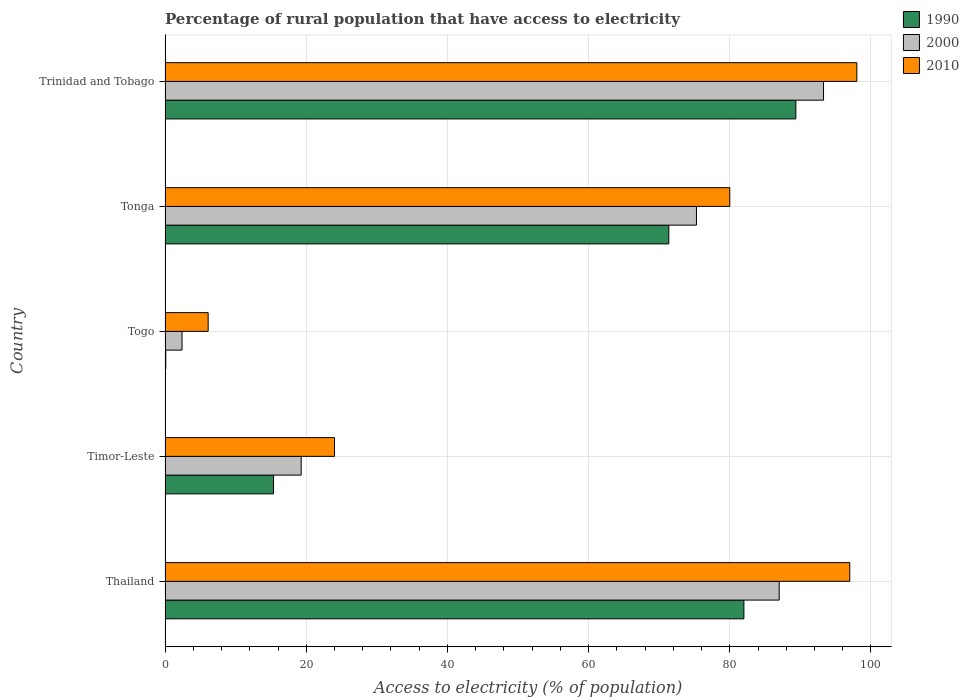How many groups of bars are there?
Make the answer very short. 5. Are the number of bars per tick equal to the number of legend labels?
Provide a succinct answer. Yes. Are the number of bars on each tick of the Y-axis equal?
Your answer should be very brief. Yes. What is the label of the 2nd group of bars from the top?
Your answer should be very brief. Tonga. In how many cases, is the number of bars for a given country not equal to the number of legend labels?
Your response must be concise. 0. Across all countries, what is the maximum percentage of rural population that have access to electricity in 2000?
Provide a short and direct response. 93.28. In which country was the percentage of rural population that have access to electricity in 1990 maximum?
Make the answer very short. Trinidad and Tobago. In which country was the percentage of rural population that have access to electricity in 2000 minimum?
Give a very brief answer. Togo. What is the total percentage of rural population that have access to electricity in 2000 in the graph?
Keep it short and to the point. 277.24. What is the difference between the percentage of rural population that have access to electricity in 2000 in Thailand and that in Timor-Leste?
Your response must be concise. 67.72. What is the difference between the percentage of rural population that have access to electricity in 2000 in Tonga and the percentage of rural population that have access to electricity in 1990 in Thailand?
Your answer should be very brief. -6.72. What is the average percentage of rural population that have access to electricity in 2010 per country?
Your answer should be very brief. 61.02. What is the difference between the percentage of rural population that have access to electricity in 1990 and percentage of rural population that have access to electricity in 2000 in Trinidad and Tobago?
Keep it short and to the point. -3.92. In how many countries, is the percentage of rural population that have access to electricity in 1990 greater than 56 %?
Your response must be concise. 3. What is the ratio of the percentage of rural population that have access to electricity in 2000 in Thailand to that in Tonga?
Your response must be concise. 1.16. What is the difference between the highest and the second highest percentage of rural population that have access to electricity in 2000?
Offer a very short reply. 6.28. What is the difference between the highest and the lowest percentage of rural population that have access to electricity in 2000?
Ensure brevity in your answer.  90.88. In how many countries, is the percentage of rural population that have access to electricity in 1990 greater than the average percentage of rural population that have access to electricity in 1990 taken over all countries?
Offer a very short reply. 3. What does the 2nd bar from the bottom in Thailand represents?
Your answer should be very brief. 2000. How many bars are there?
Offer a very short reply. 15. Are all the bars in the graph horizontal?
Your answer should be very brief. Yes. How many countries are there in the graph?
Make the answer very short. 5. What is the difference between two consecutive major ticks on the X-axis?
Provide a succinct answer. 20. Are the values on the major ticks of X-axis written in scientific E-notation?
Give a very brief answer. No. Does the graph contain grids?
Your response must be concise. Yes. Where does the legend appear in the graph?
Ensure brevity in your answer.  Top right. How many legend labels are there?
Make the answer very short. 3. What is the title of the graph?
Provide a succinct answer. Percentage of rural population that have access to electricity. Does "1971" appear as one of the legend labels in the graph?
Provide a short and direct response. No. What is the label or title of the X-axis?
Offer a very short reply. Access to electricity (% of population). What is the Access to electricity (% of population) of 2010 in Thailand?
Ensure brevity in your answer.  97. What is the Access to electricity (% of population) in 1990 in Timor-Leste?
Your answer should be compact. 15.36. What is the Access to electricity (% of population) in 2000 in Timor-Leste?
Your answer should be very brief. 19.28. What is the Access to electricity (% of population) of 2010 in Timor-Leste?
Keep it short and to the point. 24. What is the Access to electricity (% of population) of 2010 in Togo?
Give a very brief answer. 6.1. What is the Access to electricity (% of population) in 1990 in Tonga?
Keep it short and to the point. 71.36. What is the Access to electricity (% of population) in 2000 in Tonga?
Offer a terse response. 75.28. What is the Access to electricity (% of population) of 1990 in Trinidad and Tobago?
Offer a terse response. 89.36. What is the Access to electricity (% of population) of 2000 in Trinidad and Tobago?
Make the answer very short. 93.28. What is the Access to electricity (% of population) in 2010 in Trinidad and Tobago?
Provide a short and direct response. 98. Across all countries, what is the maximum Access to electricity (% of population) of 1990?
Your response must be concise. 89.36. Across all countries, what is the maximum Access to electricity (% of population) of 2000?
Provide a short and direct response. 93.28. Across all countries, what is the minimum Access to electricity (% of population) of 1990?
Your answer should be very brief. 0.1. Across all countries, what is the minimum Access to electricity (% of population) of 2000?
Your response must be concise. 2.4. Across all countries, what is the minimum Access to electricity (% of population) of 2010?
Provide a succinct answer. 6.1. What is the total Access to electricity (% of population) in 1990 in the graph?
Give a very brief answer. 258.18. What is the total Access to electricity (% of population) of 2000 in the graph?
Provide a succinct answer. 277.24. What is the total Access to electricity (% of population) of 2010 in the graph?
Provide a succinct answer. 305.1. What is the difference between the Access to electricity (% of population) of 1990 in Thailand and that in Timor-Leste?
Offer a very short reply. 66.64. What is the difference between the Access to electricity (% of population) in 2000 in Thailand and that in Timor-Leste?
Make the answer very short. 67.72. What is the difference between the Access to electricity (% of population) in 1990 in Thailand and that in Togo?
Keep it short and to the point. 81.9. What is the difference between the Access to electricity (% of population) in 2000 in Thailand and that in Togo?
Ensure brevity in your answer.  84.6. What is the difference between the Access to electricity (% of population) in 2010 in Thailand and that in Togo?
Make the answer very short. 90.9. What is the difference between the Access to electricity (% of population) in 1990 in Thailand and that in Tonga?
Give a very brief answer. 10.64. What is the difference between the Access to electricity (% of population) in 2000 in Thailand and that in Tonga?
Your answer should be very brief. 11.72. What is the difference between the Access to electricity (% of population) of 2010 in Thailand and that in Tonga?
Make the answer very short. 17. What is the difference between the Access to electricity (% of population) in 1990 in Thailand and that in Trinidad and Tobago?
Make the answer very short. -7.36. What is the difference between the Access to electricity (% of population) of 2000 in Thailand and that in Trinidad and Tobago?
Offer a terse response. -6.28. What is the difference between the Access to electricity (% of population) in 1990 in Timor-Leste and that in Togo?
Your answer should be very brief. 15.26. What is the difference between the Access to electricity (% of population) in 2000 in Timor-Leste and that in Togo?
Provide a short and direct response. 16.88. What is the difference between the Access to electricity (% of population) in 1990 in Timor-Leste and that in Tonga?
Ensure brevity in your answer.  -56. What is the difference between the Access to electricity (% of population) in 2000 in Timor-Leste and that in Tonga?
Keep it short and to the point. -56. What is the difference between the Access to electricity (% of population) of 2010 in Timor-Leste and that in Tonga?
Your answer should be very brief. -56. What is the difference between the Access to electricity (% of population) of 1990 in Timor-Leste and that in Trinidad and Tobago?
Offer a terse response. -74. What is the difference between the Access to electricity (% of population) of 2000 in Timor-Leste and that in Trinidad and Tobago?
Offer a very short reply. -74. What is the difference between the Access to electricity (% of population) in 2010 in Timor-Leste and that in Trinidad and Tobago?
Offer a very short reply. -74. What is the difference between the Access to electricity (% of population) in 1990 in Togo and that in Tonga?
Ensure brevity in your answer.  -71.26. What is the difference between the Access to electricity (% of population) in 2000 in Togo and that in Tonga?
Offer a very short reply. -72.88. What is the difference between the Access to electricity (% of population) in 2010 in Togo and that in Tonga?
Your answer should be compact. -73.9. What is the difference between the Access to electricity (% of population) in 1990 in Togo and that in Trinidad and Tobago?
Your answer should be very brief. -89.26. What is the difference between the Access to electricity (% of population) of 2000 in Togo and that in Trinidad and Tobago?
Make the answer very short. -90.88. What is the difference between the Access to electricity (% of population) in 2010 in Togo and that in Trinidad and Tobago?
Provide a succinct answer. -91.9. What is the difference between the Access to electricity (% of population) in 1990 in Tonga and that in Trinidad and Tobago?
Provide a short and direct response. -18. What is the difference between the Access to electricity (% of population) in 2010 in Tonga and that in Trinidad and Tobago?
Make the answer very short. -18. What is the difference between the Access to electricity (% of population) in 1990 in Thailand and the Access to electricity (% of population) in 2000 in Timor-Leste?
Your answer should be compact. 62.72. What is the difference between the Access to electricity (% of population) in 1990 in Thailand and the Access to electricity (% of population) in 2000 in Togo?
Give a very brief answer. 79.6. What is the difference between the Access to electricity (% of population) of 1990 in Thailand and the Access to electricity (% of population) of 2010 in Togo?
Your response must be concise. 75.9. What is the difference between the Access to electricity (% of population) in 2000 in Thailand and the Access to electricity (% of population) in 2010 in Togo?
Your response must be concise. 80.9. What is the difference between the Access to electricity (% of population) of 1990 in Thailand and the Access to electricity (% of population) of 2000 in Tonga?
Give a very brief answer. 6.72. What is the difference between the Access to electricity (% of population) of 1990 in Thailand and the Access to electricity (% of population) of 2000 in Trinidad and Tobago?
Give a very brief answer. -11.28. What is the difference between the Access to electricity (% of population) of 1990 in Thailand and the Access to electricity (% of population) of 2010 in Trinidad and Tobago?
Your response must be concise. -16. What is the difference between the Access to electricity (% of population) in 2000 in Thailand and the Access to electricity (% of population) in 2010 in Trinidad and Tobago?
Your response must be concise. -11. What is the difference between the Access to electricity (% of population) of 1990 in Timor-Leste and the Access to electricity (% of population) of 2000 in Togo?
Make the answer very short. 12.96. What is the difference between the Access to electricity (% of population) of 1990 in Timor-Leste and the Access to electricity (% of population) of 2010 in Togo?
Your answer should be compact. 9.26. What is the difference between the Access to electricity (% of population) of 2000 in Timor-Leste and the Access to electricity (% of population) of 2010 in Togo?
Give a very brief answer. 13.18. What is the difference between the Access to electricity (% of population) of 1990 in Timor-Leste and the Access to electricity (% of population) of 2000 in Tonga?
Your response must be concise. -59.92. What is the difference between the Access to electricity (% of population) in 1990 in Timor-Leste and the Access to electricity (% of population) in 2010 in Tonga?
Make the answer very short. -64.64. What is the difference between the Access to electricity (% of population) in 2000 in Timor-Leste and the Access to electricity (% of population) in 2010 in Tonga?
Provide a succinct answer. -60.72. What is the difference between the Access to electricity (% of population) in 1990 in Timor-Leste and the Access to electricity (% of population) in 2000 in Trinidad and Tobago?
Ensure brevity in your answer.  -77.92. What is the difference between the Access to electricity (% of population) of 1990 in Timor-Leste and the Access to electricity (% of population) of 2010 in Trinidad and Tobago?
Provide a short and direct response. -82.64. What is the difference between the Access to electricity (% of population) in 2000 in Timor-Leste and the Access to electricity (% of population) in 2010 in Trinidad and Tobago?
Your answer should be very brief. -78.72. What is the difference between the Access to electricity (% of population) in 1990 in Togo and the Access to electricity (% of population) in 2000 in Tonga?
Give a very brief answer. -75.18. What is the difference between the Access to electricity (% of population) of 1990 in Togo and the Access to electricity (% of population) of 2010 in Tonga?
Offer a very short reply. -79.9. What is the difference between the Access to electricity (% of population) of 2000 in Togo and the Access to electricity (% of population) of 2010 in Tonga?
Your response must be concise. -77.6. What is the difference between the Access to electricity (% of population) in 1990 in Togo and the Access to electricity (% of population) in 2000 in Trinidad and Tobago?
Offer a very short reply. -93.18. What is the difference between the Access to electricity (% of population) of 1990 in Togo and the Access to electricity (% of population) of 2010 in Trinidad and Tobago?
Provide a succinct answer. -97.9. What is the difference between the Access to electricity (% of population) in 2000 in Togo and the Access to electricity (% of population) in 2010 in Trinidad and Tobago?
Give a very brief answer. -95.6. What is the difference between the Access to electricity (% of population) of 1990 in Tonga and the Access to electricity (% of population) of 2000 in Trinidad and Tobago?
Your answer should be compact. -21.92. What is the difference between the Access to electricity (% of population) in 1990 in Tonga and the Access to electricity (% of population) in 2010 in Trinidad and Tobago?
Your answer should be compact. -26.64. What is the difference between the Access to electricity (% of population) of 2000 in Tonga and the Access to electricity (% of population) of 2010 in Trinidad and Tobago?
Provide a short and direct response. -22.72. What is the average Access to electricity (% of population) in 1990 per country?
Offer a very short reply. 51.64. What is the average Access to electricity (% of population) of 2000 per country?
Ensure brevity in your answer.  55.45. What is the average Access to electricity (% of population) of 2010 per country?
Offer a very short reply. 61.02. What is the difference between the Access to electricity (% of population) in 1990 and Access to electricity (% of population) in 2000 in Thailand?
Keep it short and to the point. -5. What is the difference between the Access to electricity (% of population) of 1990 and Access to electricity (% of population) of 2010 in Thailand?
Give a very brief answer. -15. What is the difference between the Access to electricity (% of population) in 2000 and Access to electricity (% of population) in 2010 in Thailand?
Your answer should be compact. -10. What is the difference between the Access to electricity (% of population) of 1990 and Access to electricity (% of population) of 2000 in Timor-Leste?
Your answer should be compact. -3.92. What is the difference between the Access to electricity (% of population) in 1990 and Access to electricity (% of population) in 2010 in Timor-Leste?
Provide a succinct answer. -8.64. What is the difference between the Access to electricity (% of population) of 2000 and Access to electricity (% of population) of 2010 in Timor-Leste?
Give a very brief answer. -4.72. What is the difference between the Access to electricity (% of population) of 1990 and Access to electricity (% of population) of 2000 in Togo?
Your answer should be compact. -2.3. What is the difference between the Access to electricity (% of population) in 2000 and Access to electricity (% of population) in 2010 in Togo?
Give a very brief answer. -3.7. What is the difference between the Access to electricity (% of population) in 1990 and Access to electricity (% of population) in 2000 in Tonga?
Offer a terse response. -3.92. What is the difference between the Access to electricity (% of population) in 1990 and Access to electricity (% of population) in 2010 in Tonga?
Ensure brevity in your answer.  -8.64. What is the difference between the Access to electricity (% of population) of 2000 and Access to electricity (% of population) of 2010 in Tonga?
Offer a terse response. -4.72. What is the difference between the Access to electricity (% of population) of 1990 and Access to electricity (% of population) of 2000 in Trinidad and Tobago?
Offer a terse response. -3.92. What is the difference between the Access to electricity (% of population) of 1990 and Access to electricity (% of population) of 2010 in Trinidad and Tobago?
Your response must be concise. -8.64. What is the difference between the Access to electricity (% of population) in 2000 and Access to electricity (% of population) in 2010 in Trinidad and Tobago?
Offer a terse response. -4.72. What is the ratio of the Access to electricity (% of population) of 1990 in Thailand to that in Timor-Leste?
Offer a terse response. 5.34. What is the ratio of the Access to electricity (% of population) in 2000 in Thailand to that in Timor-Leste?
Ensure brevity in your answer.  4.51. What is the ratio of the Access to electricity (% of population) in 2010 in Thailand to that in Timor-Leste?
Provide a succinct answer. 4.04. What is the ratio of the Access to electricity (% of population) in 1990 in Thailand to that in Togo?
Offer a terse response. 820. What is the ratio of the Access to electricity (% of population) in 2000 in Thailand to that in Togo?
Offer a terse response. 36.25. What is the ratio of the Access to electricity (% of population) of 2010 in Thailand to that in Togo?
Make the answer very short. 15.9. What is the ratio of the Access to electricity (% of population) of 1990 in Thailand to that in Tonga?
Make the answer very short. 1.15. What is the ratio of the Access to electricity (% of population) in 2000 in Thailand to that in Tonga?
Make the answer very short. 1.16. What is the ratio of the Access to electricity (% of population) in 2010 in Thailand to that in Tonga?
Give a very brief answer. 1.21. What is the ratio of the Access to electricity (% of population) in 1990 in Thailand to that in Trinidad and Tobago?
Give a very brief answer. 0.92. What is the ratio of the Access to electricity (% of population) in 2000 in Thailand to that in Trinidad and Tobago?
Ensure brevity in your answer.  0.93. What is the ratio of the Access to electricity (% of population) in 2010 in Thailand to that in Trinidad and Tobago?
Offer a terse response. 0.99. What is the ratio of the Access to electricity (% of population) of 1990 in Timor-Leste to that in Togo?
Provide a succinct answer. 153.6. What is the ratio of the Access to electricity (% of population) of 2000 in Timor-Leste to that in Togo?
Your answer should be very brief. 8.03. What is the ratio of the Access to electricity (% of population) in 2010 in Timor-Leste to that in Togo?
Provide a succinct answer. 3.93. What is the ratio of the Access to electricity (% of population) of 1990 in Timor-Leste to that in Tonga?
Your answer should be compact. 0.22. What is the ratio of the Access to electricity (% of population) of 2000 in Timor-Leste to that in Tonga?
Offer a very short reply. 0.26. What is the ratio of the Access to electricity (% of population) in 1990 in Timor-Leste to that in Trinidad and Tobago?
Your answer should be very brief. 0.17. What is the ratio of the Access to electricity (% of population) of 2000 in Timor-Leste to that in Trinidad and Tobago?
Keep it short and to the point. 0.21. What is the ratio of the Access to electricity (% of population) of 2010 in Timor-Leste to that in Trinidad and Tobago?
Ensure brevity in your answer.  0.24. What is the ratio of the Access to electricity (% of population) of 1990 in Togo to that in Tonga?
Provide a short and direct response. 0. What is the ratio of the Access to electricity (% of population) of 2000 in Togo to that in Tonga?
Offer a very short reply. 0.03. What is the ratio of the Access to electricity (% of population) of 2010 in Togo to that in Tonga?
Offer a terse response. 0.08. What is the ratio of the Access to electricity (% of population) of 1990 in Togo to that in Trinidad and Tobago?
Give a very brief answer. 0. What is the ratio of the Access to electricity (% of population) of 2000 in Togo to that in Trinidad and Tobago?
Your answer should be compact. 0.03. What is the ratio of the Access to electricity (% of population) in 2010 in Togo to that in Trinidad and Tobago?
Offer a terse response. 0.06. What is the ratio of the Access to electricity (% of population) in 1990 in Tonga to that in Trinidad and Tobago?
Make the answer very short. 0.8. What is the ratio of the Access to electricity (% of population) of 2000 in Tonga to that in Trinidad and Tobago?
Your response must be concise. 0.81. What is the ratio of the Access to electricity (% of population) of 2010 in Tonga to that in Trinidad and Tobago?
Offer a very short reply. 0.82. What is the difference between the highest and the second highest Access to electricity (% of population) of 1990?
Offer a very short reply. 7.36. What is the difference between the highest and the second highest Access to electricity (% of population) in 2000?
Make the answer very short. 6.28. What is the difference between the highest and the lowest Access to electricity (% of population) in 1990?
Your answer should be compact. 89.26. What is the difference between the highest and the lowest Access to electricity (% of population) in 2000?
Provide a short and direct response. 90.88. What is the difference between the highest and the lowest Access to electricity (% of population) of 2010?
Your answer should be compact. 91.9. 